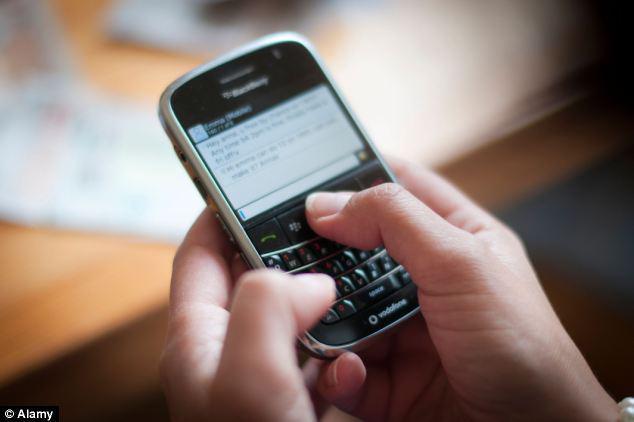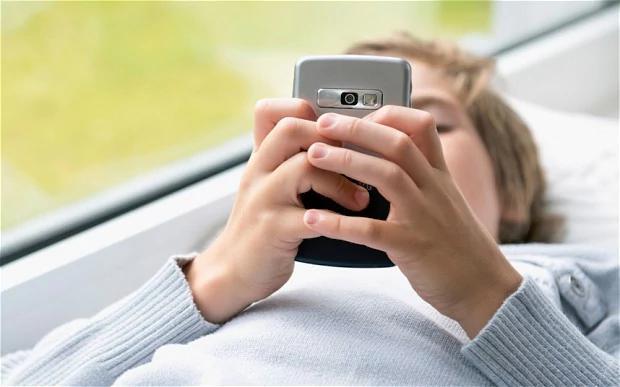The first image is the image on the left, the second image is the image on the right. Considering the images on both sides, is "The phone in the left image is black and the phone in the right image is white." valid? Answer yes or no. No. The first image is the image on the left, the second image is the image on the right. Evaluate the accuracy of this statement regarding the images: "In one of the images, a person is typing on a phone with physical keys.". Is it true? Answer yes or no. Yes. 